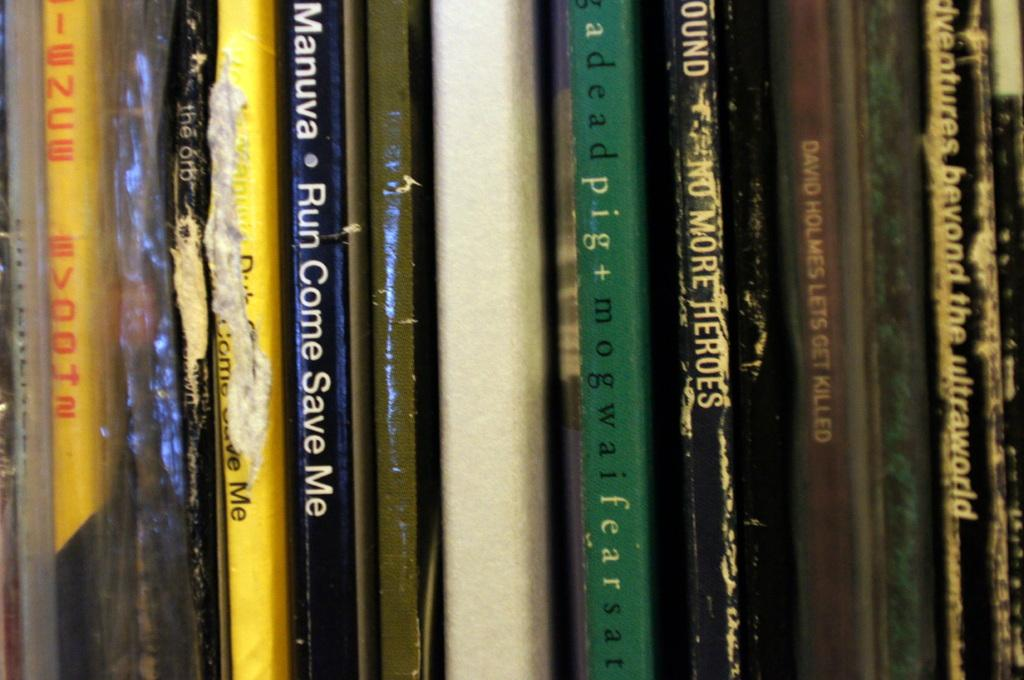<image>
Write a terse but informative summary of the picture. An assortment of books stacked upright vertically with one titled Run Come Save Me. 